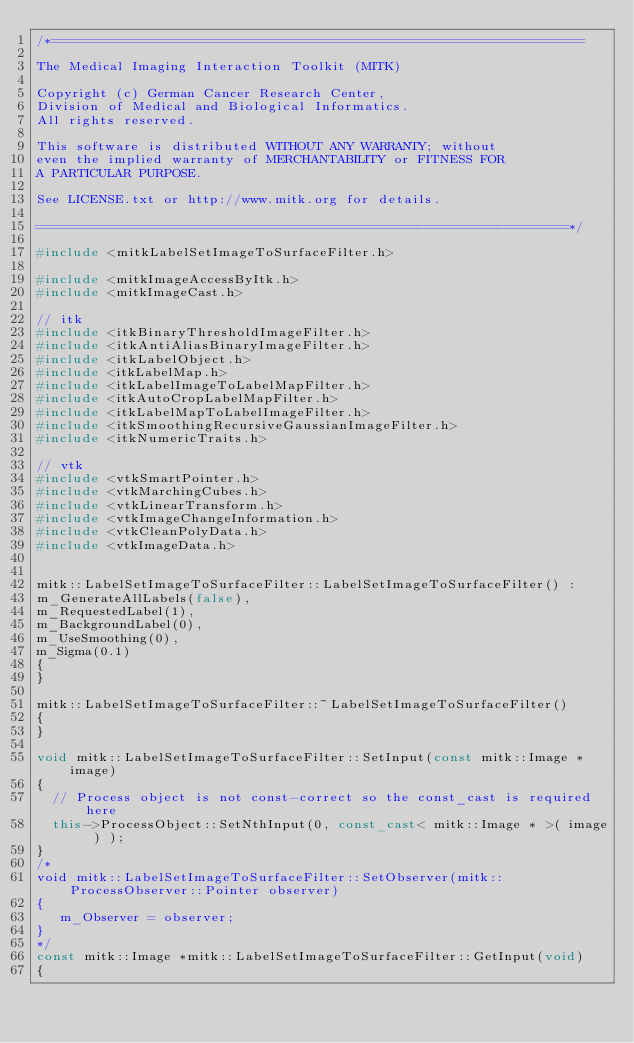<code> <loc_0><loc_0><loc_500><loc_500><_C++_>/*===================================================================

The Medical Imaging Interaction Toolkit (MITK)

Copyright (c) German Cancer Research Center,
Division of Medical and Biological Informatics.
All rights reserved.

This software is distributed WITHOUT ANY WARRANTY; without
even the implied warranty of MERCHANTABILITY or FITNESS FOR
A PARTICULAR PURPOSE.

See LICENSE.txt or http://www.mitk.org for details.

===================================================================*/

#include <mitkLabelSetImageToSurfaceFilter.h>

#include <mitkImageAccessByItk.h>
#include <mitkImageCast.h>

// itk
#include <itkBinaryThresholdImageFilter.h>
#include <itkAntiAliasBinaryImageFilter.h>
#include <itkLabelObject.h>
#include <itkLabelMap.h>
#include <itkLabelImageToLabelMapFilter.h>
#include <itkAutoCropLabelMapFilter.h>
#include <itkLabelMapToLabelImageFilter.h>
#include <itkSmoothingRecursiveGaussianImageFilter.h>
#include <itkNumericTraits.h>

// vtk
#include <vtkSmartPointer.h>
#include <vtkMarchingCubes.h>
#include <vtkLinearTransform.h>
#include <vtkImageChangeInformation.h>
#include <vtkCleanPolyData.h>
#include <vtkImageData.h>


mitk::LabelSetImageToSurfaceFilter::LabelSetImageToSurfaceFilter() :
m_GenerateAllLabels(false),
m_RequestedLabel(1),
m_BackgroundLabel(0),
m_UseSmoothing(0),
m_Sigma(0.1)
{
}

mitk::LabelSetImageToSurfaceFilter::~LabelSetImageToSurfaceFilter()
{
}

void mitk::LabelSetImageToSurfaceFilter::SetInput(const mitk::Image *image)
{
  // Process object is not const-correct so the const_cast is required here
  this->ProcessObject::SetNthInput(0, const_cast< mitk::Image * >( image ) );
}
/*
void mitk::LabelSetImageToSurfaceFilter::SetObserver(mitk::ProcessObserver::Pointer observer)
{
   m_Observer = observer;
}
*/
const mitk::Image *mitk::LabelSetImageToSurfaceFilter::GetInput(void)
{</code> 